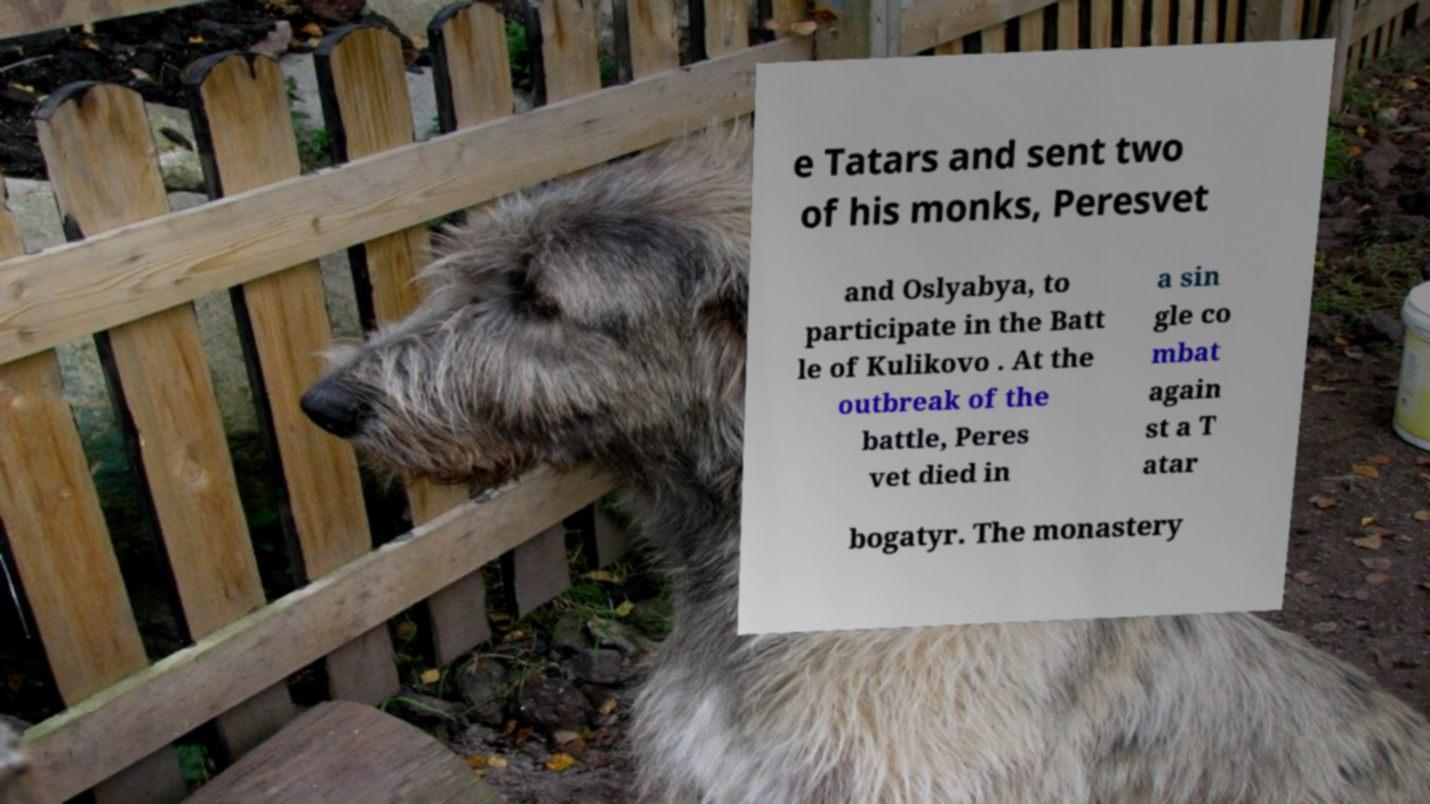There's text embedded in this image that I need extracted. Can you transcribe it verbatim? e Tatars and sent two of his monks, Peresvet and Oslyabya, to participate in the Batt le of Kulikovo . At the outbreak of the battle, Peres vet died in a sin gle co mbat again st a T atar bogatyr. The monastery 